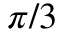<formula> <loc_0><loc_0><loc_500><loc_500>\pi / 3</formula> 